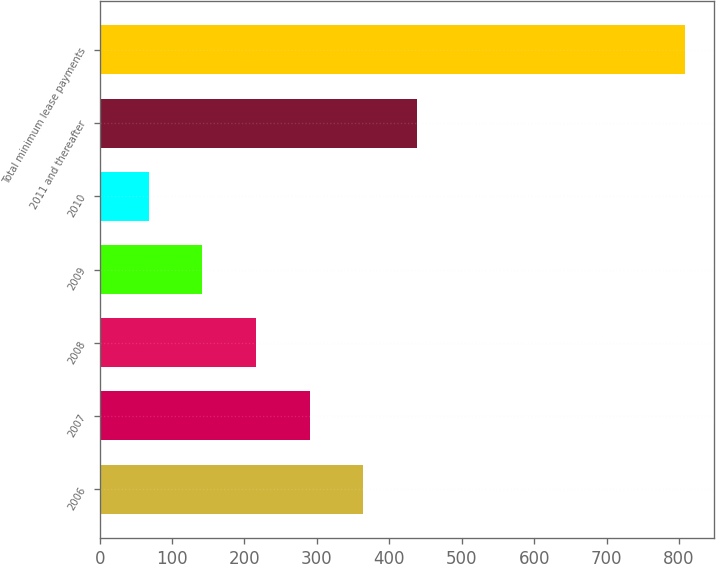Convert chart. <chart><loc_0><loc_0><loc_500><loc_500><bar_chart><fcel>2006<fcel>2007<fcel>2008<fcel>2009<fcel>2010<fcel>2011 and thereafter<fcel>Total minimum lease payments<nl><fcel>364<fcel>290<fcel>216<fcel>142<fcel>68<fcel>438<fcel>808<nl></chart> 